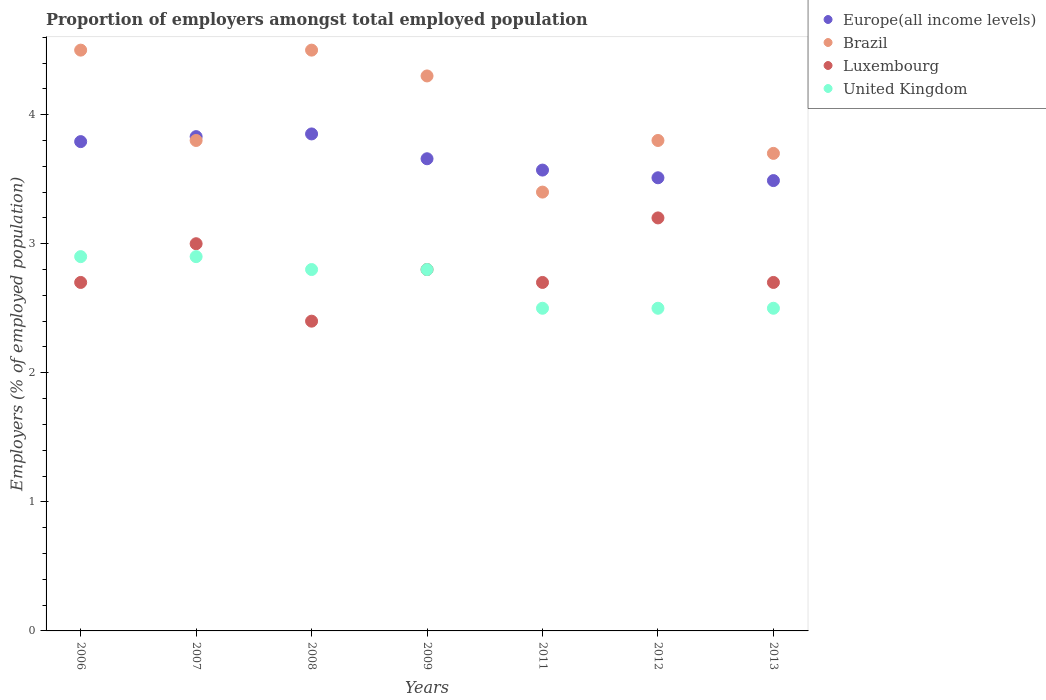What is the proportion of employers in Brazil in 2012?
Provide a succinct answer. 3.8. Across all years, what is the minimum proportion of employers in Brazil?
Your answer should be compact. 3.4. In which year was the proportion of employers in Luxembourg minimum?
Make the answer very short. 2008. What is the total proportion of employers in Luxembourg in the graph?
Ensure brevity in your answer.  19.5. What is the difference between the proportion of employers in Europe(all income levels) in 2006 and the proportion of employers in Brazil in 2008?
Offer a very short reply. -0.71. What is the average proportion of employers in Europe(all income levels) per year?
Your answer should be compact. 3.67. In the year 2013, what is the difference between the proportion of employers in United Kingdom and proportion of employers in Brazil?
Your answer should be compact. -1.2. What is the ratio of the proportion of employers in United Kingdom in 2007 to that in 2011?
Ensure brevity in your answer.  1.16. Is the proportion of employers in Europe(all income levels) in 2006 less than that in 2011?
Make the answer very short. No. Is the difference between the proportion of employers in United Kingdom in 2011 and 2012 greater than the difference between the proportion of employers in Brazil in 2011 and 2012?
Offer a very short reply. Yes. What is the difference between the highest and the second highest proportion of employers in Europe(all income levels)?
Provide a short and direct response. 0.02. What is the difference between the highest and the lowest proportion of employers in Europe(all income levels)?
Ensure brevity in your answer.  0.36. In how many years, is the proportion of employers in Europe(all income levels) greater than the average proportion of employers in Europe(all income levels) taken over all years?
Ensure brevity in your answer.  3. Is the sum of the proportion of employers in United Kingdom in 2008 and 2013 greater than the maximum proportion of employers in Europe(all income levels) across all years?
Offer a very short reply. Yes. Does the proportion of employers in United Kingdom monotonically increase over the years?
Your response must be concise. No. Is the proportion of employers in Luxembourg strictly greater than the proportion of employers in Brazil over the years?
Offer a very short reply. No. Is the proportion of employers in Europe(all income levels) strictly less than the proportion of employers in United Kingdom over the years?
Make the answer very short. No. How many dotlines are there?
Offer a very short reply. 4. What is the difference between two consecutive major ticks on the Y-axis?
Keep it short and to the point. 1. Where does the legend appear in the graph?
Your answer should be very brief. Top right. How many legend labels are there?
Your answer should be very brief. 4. How are the legend labels stacked?
Give a very brief answer. Vertical. What is the title of the graph?
Your response must be concise. Proportion of employers amongst total employed population. What is the label or title of the X-axis?
Offer a very short reply. Years. What is the label or title of the Y-axis?
Provide a short and direct response. Employers (% of employed population). What is the Employers (% of employed population) of Europe(all income levels) in 2006?
Keep it short and to the point. 3.79. What is the Employers (% of employed population) in Luxembourg in 2006?
Your response must be concise. 2.7. What is the Employers (% of employed population) in United Kingdom in 2006?
Make the answer very short. 2.9. What is the Employers (% of employed population) of Europe(all income levels) in 2007?
Your answer should be very brief. 3.83. What is the Employers (% of employed population) in Brazil in 2007?
Your response must be concise. 3.8. What is the Employers (% of employed population) of United Kingdom in 2007?
Your response must be concise. 2.9. What is the Employers (% of employed population) in Europe(all income levels) in 2008?
Offer a terse response. 3.85. What is the Employers (% of employed population) of Brazil in 2008?
Make the answer very short. 4.5. What is the Employers (% of employed population) of Luxembourg in 2008?
Make the answer very short. 2.4. What is the Employers (% of employed population) of United Kingdom in 2008?
Your answer should be compact. 2.8. What is the Employers (% of employed population) in Europe(all income levels) in 2009?
Offer a very short reply. 3.66. What is the Employers (% of employed population) of Brazil in 2009?
Your response must be concise. 4.3. What is the Employers (% of employed population) of Luxembourg in 2009?
Make the answer very short. 2.8. What is the Employers (% of employed population) in United Kingdom in 2009?
Your answer should be compact. 2.8. What is the Employers (% of employed population) in Europe(all income levels) in 2011?
Give a very brief answer. 3.57. What is the Employers (% of employed population) of Brazil in 2011?
Keep it short and to the point. 3.4. What is the Employers (% of employed population) in Luxembourg in 2011?
Your answer should be very brief. 2.7. What is the Employers (% of employed population) of Europe(all income levels) in 2012?
Provide a short and direct response. 3.51. What is the Employers (% of employed population) of Brazil in 2012?
Your response must be concise. 3.8. What is the Employers (% of employed population) of Luxembourg in 2012?
Keep it short and to the point. 3.2. What is the Employers (% of employed population) of Europe(all income levels) in 2013?
Provide a short and direct response. 3.49. What is the Employers (% of employed population) of Brazil in 2013?
Keep it short and to the point. 3.7. What is the Employers (% of employed population) of Luxembourg in 2013?
Ensure brevity in your answer.  2.7. Across all years, what is the maximum Employers (% of employed population) of Europe(all income levels)?
Offer a very short reply. 3.85. Across all years, what is the maximum Employers (% of employed population) in Luxembourg?
Your response must be concise. 3.2. Across all years, what is the maximum Employers (% of employed population) in United Kingdom?
Give a very brief answer. 2.9. Across all years, what is the minimum Employers (% of employed population) in Europe(all income levels)?
Provide a short and direct response. 3.49. Across all years, what is the minimum Employers (% of employed population) of Brazil?
Offer a very short reply. 3.4. Across all years, what is the minimum Employers (% of employed population) in Luxembourg?
Provide a succinct answer. 2.4. What is the total Employers (% of employed population) in Europe(all income levels) in the graph?
Offer a very short reply. 25.7. What is the total Employers (% of employed population) in Brazil in the graph?
Provide a short and direct response. 28. What is the total Employers (% of employed population) in Luxembourg in the graph?
Your response must be concise. 19.5. What is the difference between the Employers (% of employed population) in Europe(all income levels) in 2006 and that in 2007?
Ensure brevity in your answer.  -0.04. What is the difference between the Employers (% of employed population) of Luxembourg in 2006 and that in 2007?
Provide a short and direct response. -0.3. What is the difference between the Employers (% of employed population) of United Kingdom in 2006 and that in 2007?
Provide a succinct answer. 0. What is the difference between the Employers (% of employed population) in Europe(all income levels) in 2006 and that in 2008?
Give a very brief answer. -0.06. What is the difference between the Employers (% of employed population) of Brazil in 2006 and that in 2008?
Keep it short and to the point. 0. What is the difference between the Employers (% of employed population) of Luxembourg in 2006 and that in 2008?
Offer a very short reply. 0.3. What is the difference between the Employers (% of employed population) of United Kingdom in 2006 and that in 2008?
Offer a very short reply. 0.1. What is the difference between the Employers (% of employed population) of Europe(all income levels) in 2006 and that in 2009?
Make the answer very short. 0.13. What is the difference between the Employers (% of employed population) in Europe(all income levels) in 2006 and that in 2011?
Your response must be concise. 0.22. What is the difference between the Employers (% of employed population) of Luxembourg in 2006 and that in 2011?
Keep it short and to the point. 0. What is the difference between the Employers (% of employed population) in Europe(all income levels) in 2006 and that in 2012?
Give a very brief answer. 0.28. What is the difference between the Employers (% of employed population) of United Kingdom in 2006 and that in 2012?
Your answer should be compact. 0.4. What is the difference between the Employers (% of employed population) in Europe(all income levels) in 2006 and that in 2013?
Your answer should be compact. 0.3. What is the difference between the Employers (% of employed population) in Luxembourg in 2006 and that in 2013?
Provide a succinct answer. 0. What is the difference between the Employers (% of employed population) of Europe(all income levels) in 2007 and that in 2008?
Your answer should be compact. -0.02. What is the difference between the Employers (% of employed population) of Brazil in 2007 and that in 2008?
Offer a terse response. -0.7. What is the difference between the Employers (% of employed population) of Luxembourg in 2007 and that in 2008?
Your answer should be compact. 0.6. What is the difference between the Employers (% of employed population) of Europe(all income levels) in 2007 and that in 2009?
Your response must be concise. 0.17. What is the difference between the Employers (% of employed population) of Luxembourg in 2007 and that in 2009?
Your answer should be very brief. 0.2. What is the difference between the Employers (% of employed population) of Europe(all income levels) in 2007 and that in 2011?
Your answer should be compact. 0.26. What is the difference between the Employers (% of employed population) in Brazil in 2007 and that in 2011?
Provide a short and direct response. 0.4. What is the difference between the Employers (% of employed population) of United Kingdom in 2007 and that in 2011?
Provide a short and direct response. 0.4. What is the difference between the Employers (% of employed population) of Europe(all income levels) in 2007 and that in 2012?
Offer a very short reply. 0.32. What is the difference between the Employers (% of employed population) of Luxembourg in 2007 and that in 2012?
Give a very brief answer. -0.2. What is the difference between the Employers (% of employed population) of Europe(all income levels) in 2007 and that in 2013?
Ensure brevity in your answer.  0.34. What is the difference between the Employers (% of employed population) of Brazil in 2007 and that in 2013?
Your answer should be compact. 0.1. What is the difference between the Employers (% of employed population) in Europe(all income levels) in 2008 and that in 2009?
Offer a terse response. 0.19. What is the difference between the Employers (% of employed population) in Brazil in 2008 and that in 2009?
Offer a terse response. 0.2. What is the difference between the Employers (% of employed population) of United Kingdom in 2008 and that in 2009?
Make the answer very short. 0. What is the difference between the Employers (% of employed population) in Europe(all income levels) in 2008 and that in 2011?
Offer a terse response. 0.28. What is the difference between the Employers (% of employed population) in Brazil in 2008 and that in 2011?
Keep it short and to the point. 1.1. What is the difference between the Employers (% of employed population) in United Kingdom in 2008 and that in 2011?
Offer a very short reply. 0.3. What is the difference between the Employers (% of employed population) of Europe(all income levels) in 2008 and that in 2012?
Your answer should be compact. 0.34. What is the difference between the Employers (% of employed population) of Europe(all income levels) in 2008 and that in 2013?
Give a very brief answer. 0.36. What is the difference between the Employers (% of employed population) in Brazil in 2008 and that in 2013?
Offer a terse response. 0.8. What is the difference between the Employers (% of employed population) in Luxembourg in 2008 and that in 2013?
Your answer should be compact. -0.3. What is the difference between the Employers (% of employed population) of United Kingdom in 2008 and that in 2013?
Your answer should be very brief. 0.3. What is the difference between the Employers (% of employed population) of Europe(all income levels) in 2009 and that in 2011?
Your answer should be very brief. 0.09. What is the difference between the Employers (% of employed population) in Brazil in 2009 and that in 2011?
Give a very brief answer. 0.9. What is the difference between the Employers (% of employed population) of Luxembourg in 2009 and that in 2011?
Your answer should be compact. 0.1. What is the difference between the Employers (% of employed population) in Europe(all income levels) in 2009 and that in 2012?
Give a very brief answer. 0.15. What is the difference between the Employers (% of employed population) of Luxembourg in 2009 and that in 2012?
Ensure brevity in your answer.  -0.4. What is the difference between the Employers (% of employed population) in United Kingdom in 2009 and that in 2012?
Make the answer very short. 0.3. What is the difference between the Employers (% of employed population) of Europe(all income levels) in 2009 and that in 2013?
Ensure brevity in your answer.  0.17. What is the difference between the Employers (% of employed population) in Brazil in 2009 and that in 2013?
Provide a succinct answer. 0.6. What is the difference between the Employers (% of employed population) in Luxembourg in 2009 and that in 2013?
Offer a very short reply. 0.1. What is the difference between the Employers (% of employed population) of United Kingdom in 2009 and that in 2013?
Your answer should be compact. 0.3. What is the difference between the Employers (% of employed population) in Europe(all income levels) in 2011 and that in 2012?
Offer a terse response. 0.06. What is the difference between the Employers (% of employed population) in Brazil in 2011 and that in 2012?
Ensure brevity in your answer.  -0.4. What is the difference between the Employers (% of employed population) in United Kingdom in 2011 and that in 2012?
Offer a terse response. 0. What is the difference between the Employers (% of employed population) of Europe(all income levels) in 2011 and that in 2013?
Provide a short and direct response. 0.08. What is the difference between the Employers (% of employed population) of Europe(all income levels) in 2012 and that in 2013?
Ensure brevity in your answer.  0.02. What is the difference between the Employers (% of employed population) of Brazil in 2012 and that in 2013?
Ensure brevity in your answer.  0.1. What is the difference between the Employers (% of employed population) of United Kingdom in 2012 and that in 2013?
Keep it short and to the point. 0. What is the difference between the Employers (% of employed population) of Europe(all income levels) in 2006 and the Employers (% of employed population) of Brazil in 2007?
Offer a terse response. -0.01. What is the difference between the Employers (% of employed population) in Europe(all income levels) in 2006 and the Employers (% of employed population) in Luxembourg in 2007?
Make the answer very short. 0.79. What is the difference between the Employers (% of employed population) of Europe(all income levels) in 2006 and the Employers (% of employed population) of United Kingdom in 2007?
Offer a terse response. 0.89. What is the difference between the Employers (% of employed population) of Brazil in 2006 and the Employers (% of employed population) of Luxembourg in 2007?
Offer a terse response. 1.5. What is the difference between the Employers (% of employed population) of Brazil in 2006 and the Employers (% of employed population) of United Kingdom in 2007?
Provide a succinct answer. 1.6. What is the difference between the Employers (% of employed population) in Europe(all income levels) in 2006 and the Employers (% of employed population) in Brazil in 2008?
Offer a terse response. -0.71. What is the difference between the Employers (% of employed population) of Europe(all income levels) in 2006 and the Employers (% of employed population) of Luxembourg in 2008?
Make the answer very short. 1.39. What is the difference between the Employers (% of employed population) of Europe(all income levels) in 2006 and the Employers (% of employed population) of United Kingdom in 2008?
Provide a short and direct response. 0.99. What is the difference between the Employers (% of employed population) in Brazil in 2006 and the Employers (% of employed population) in Luxembourg in 2008?
Make the answer very short. 2.1. What is the difference between the Employers (% of employed population) of Brazil in 2006 and the Employers (% of employed population) of United Kingdom in 2008?
Provide a succinct answer. 1.7. What is the difference between the Employers (% of employed population) in Luxembourg in 2006 and the Employers (% of employed population) in United Kingdom in 2008?
Keep it short and to the point. -0.1. What is the difference between the Employers (% of employed population) in Europe(all income levels) in 2006 and the Employers (% of employed population) in Brazil in 2009?
Your answer should be compact. -0.51. What is the difference between the Employers (% of employed population) of Europe(all income levels) in 2006 and the Employers (% of employed population) of Luxembourg in 2009?
Your answer should be very brief. 0.99. What is the difference between the Employers (% of employed population) in Europe(all income levels) in 2006 and the Employers (% of employed population) in United Kingdom in 2009?
Keep it short and to the point. 0.99. What is the difference between the Employers (% of employed population) in Brazil in 2006 and the Employers (% of employed population) in Luxembourg in 2009?
Provide a succinct answer. 1.7. What is the difference between the Employers (% of employed population) of Brazil in 2006 and the Employers (% of employed population) of United Kingdom in 2009?
Your answer should be compact. 1.7. What is the difference between the Employers (% of employed population) of Europe(all income levels) in 2006 and the Employers (% of employed population) of Brazil in 2011?
Give a very brief answer. 0.39. What is the difference between the Employers (% of employed population) in Europe(all income levels) in 2006 and the Employers (% of employed population) in Luxembourg in 2011?
Give a very brief answer. 1.09. What is the difference between the Employers (% of employed population) in Europe(all income levels) in 2006 and the Employers (% of employed population) in United Kingdom in 2011?
Offer a very short reply. 1.29. What is the difference between the Employers (% of employed population) of Brazil in 2006 and the Employers (% of employed population) of Luxembourg in 2011?
Your answer should be very brief. 1.8. What is the difference between the Employers (% of employed population) in Brazil in 2006 and the Employers (% of employed population) in United Kingdom in 2011?
Provide a short and direct response. 2. What is the difference between the Employers (% of employed population) in Europe(all income levels) in 2006 and the Employers (% of employed population) in Brazil in 2012?
Offer a terse response. -0.01. What is the difference between the Employers (% of employed population) of Europe(all income levels) in 2006 and the Employers (% of employed population) of Luxembourg in 2012?
Make the answer very short. 0.59. What is the difference between the Employers (% of employed population) of Europe(all income levels) in 2006 and the Employers (% of employed population) of United Kingdom in 2012?
Provide a short and direct response. 1.29. What is the difference between the Employers (% of employed population) in Brazil in 2006 and the Employers (% of employed population) in Luxembourg in 2012?
Offer a terse response. 1.3. What is the difference between the Employers (% of employed population) in Brazil in 2006 and the Employers (% of employed population) in United Kingdom in 2012?
Make the answer very short. 2. What is the difference between the Employers (% of employed population) in Luxembourg in 2006 and the Employers (% of employed population) in United Kingdom in 2012?
Provide a short and direct response. 0.2. What is the difference between the Employers (% of employed population) in Europe(all income levels) in 2006 and the Employers (% of employed population) in Brazil in 2013?
Provide a succinct answer. 0.09. What is the difference between the Employers (% of employed population) in Europe(all income levels) in 2006 and the Employers (% of employed population) in Luxembourg in 2013?
Ensure brevity in your answer.  1.09. What is the difference between the Employers (% of employed population) of Europe(all income levels) in 2006 and the Employers (% of employed population) of United Kingdom in 2013?
Ensure brevity in your answer.  1.29. What is the difference between the Employers (% of employed population) of Brazil in 2006 and the Employers (% of employed population) of Luxembourg in 2013?
Ensure brevity in your answer.  1.8. What is the difference between the Employers (% of employed population) of Brazil in 2006 and the Employers (% of employed population) of United Kingdom in 2013?
Provide a succinct answer. 2. What is the difference between the Employers (% of employed population) in Europe(all income levels) in 2007 and the Employers (% of employed population) in Brazil in 2008?
Provide a short and direct response. -0.67. What is the difference between the Employers (% of employed population) in Europe(all income levels) in 2007 and the Employers (% of employed population) in Luxembourg in 2008?
Provide a short and direct response. 1.43. What is the difference between the Employers (% of employed population) of Europe(all income levels) in 2007 and the Employers (% of employed population) of United Kingdom in 2008?
Your response must be concise. 1.03. What is the difference between the Employers (% of employed population) of Luxembourg in 2007 and the Employers (% of employed population) of United Kingdom in 2008?
Keep it short and to the point. 0.2. What is the difference between the Employers (% of employed population) in Europe(all income levels) in 2007 and the Employers (% of employed population) in Brazil in 2009?
Ensure brevity in your answer.  -0.47. What is the difference between the Employers (% of employed population) of Europe(all income levels) in 2007 and the Employers (% of employed population) of Luxembourg in 2009?
Your response must be concise. 1.03. What is the difference between the Employers (% of employed population) of Europe(all income levels) in 2007 and the Employers (% of employed population) of United Kingdom in 2009?
Provide a succinct answer. 1.03. What is the difference between the Employers (% of employed population) of Brazil in 2007 and the Employers (% of employed population) of Luxembourg in 2009?
Keep it short and to the point. 1. What is the difference between the Employers (% of employed population) of Brazil in 2007 and the Employers (% of employed population) of United Kingdom in 2009?
Provide a succinct answer. 1. What is the difference between the Employers (% of employed population) of Luxembourg in 2007 and the Employers (% of employed population) of United Kingdom in 2009?
Keep it short and to the point. 0.2. What is the difference between the Employers (% of employed population) of Europe(all income levels) in 2007 and the Employers (% of employed population) of Brazil in 2011?
Your response must be concise. 0.43. What is the difference between the Employers (% of employed population) in Europe(all income levels) in 2007 and the Employers (% of employed population) in Luxembourg in 2011?
Your answer should be very brief. 1.13. What is the difference between the Employers (% of employed population) in Europe(all income levels) in 2007 and the Employers (% of employed population) in United Kingdom in 2011?
Give a very brief answer. 1.33. What is the difference between the Employers (% of employed population) in Brazil in 2007 and the Employers (% of employed population) in Luxembourg in 2011?
Provide a short and direct response. 1.1. What is the difference between the Employers (% of employed population) in Brazil in 2007 and the Employers (% of employed population) in United Kingdom in 2011?
Provide a short and direct response. 1.3. What is the difference between the Employers (% of employed population) of Europe(all income levels) in 2007 and the Employers (% of employed population) of Brazil in 2012?
Make the answer very short. 0.03. What is the difference between the Employers (% of employed population) of Europe(all income levels) in 2007 and the Employers (% of employed population) of Luxembourg in 2012?
Make the answer very short. 0.63. What is the difference between the Employers (% of employed population) in Europe(all income levels) in 2007 and the Employers (% of employed population) in United Kingdom in 2012?
Make the answer very short. 1.33. What is the difference between the Employers (% of employed population) of Brazil in 2007 and the Employers (% of employed population) of Luxembourg in 2012?
Offer a terse response. 0.6. What is the difference between the Employers (% of employed population) of Brazil in 2007 and the Employers (% of employed population) of United Kingdom in 2012?
Your answer should be compact. 1.3. What is the difference between the Employers (% of employed population) of Europe(all income levels) in 2007 and the Employers (% of employed population) of Brazil in 2013?
Keep it short and to the point. 0.13. What is the difference between the Employers (% of employed population) of Europe(all income levels) in 2007 and the Employers (% of employed population) of Luxembourg in 2013?
Provide a short and direct response. 1.13. What is the difference between the Employers (% of employed population) of Europe(all income levels) in 2007 and the Employers (% of employed population) of United Kingdom in 2013?
Ensure brevity in your answer.  1.33. What is the difference between the Employers (% of employed population) of Brazil in 2007 and the Employers (% of employed population) of Luxembourg in 2013?
Your answer should be very brief. 1.1. What is the difference between the Employers (% of employed population) of Brazil in 2007 and the Employers (% of employed population) of United Kingdom in 2013?
Your answer should be very brief. 1.3. What is the difference between the Employers (% of employed population) in Luxembourg in 2007 and the Employers (% of employed population) in United Kingdom in 2013?
Your answer should be compact. 0.5. What is the difference between the Employers (% of employed population) of Europe(all income levels) in 2008 and the Employers (% of employed population) of Brazil in 2009?
Your answer should be compact. -0.45. What is the difference between the Employers (% of employed population) in Europe(all income levels) in 2008 and the Employers (% of employed population) in Luxembourg in 2009?
Keep it short and to the point. 1.05. What is the difference between the Employers (% of employed population) of Europe(all income levels) in 2008 and the Employers (% of employed population) of United Kingdom in 2009?
Your response must be concise. 1.05. What is the difference between the Employers (% of employed population) in Luxembourg in 2008 and the Employers (% of employed population) in United Kingdom in 2009?
Make the answer very short. -0.4. What is the difference between the Employers (% of employed population) in Europe(all income levels) in 2008 and the Employers (% of employed population) in Brazil in 2011?
Offer a very short reply. 0.45. What is the difference between the Employers (% of employed population) of Europe(all income levels) in 2008 and the Employers (% of employed population) of Luxembourg in 2011?
Provide a short and direct response. 1.15. What is the difference between the Employers (% of employed population) in Europe(all income levels) in 2008 and the Employers (% of employed population) in United Kingdom in 2011?
Your answer should be compact. 1.35. What is the difference between the Employers (% of employed population) of Brazil in 2008 and the Employers (% of employed population) of United Kingdom in 2011?
Keep it short and to the point. 2. What is the difference between the Employers (% of employed population) of Europe(all income levels) in 2008 and the Employers (% of employed population) of Brazil in 2012?
Provide a short and direct response. 0.05. What is the difference between the Employers (% of employed population) in Europe(all income levels) in 2008 and the Employers (% of employed population) in Luxembourg in 2012?
Your response must be concise. 0.65. What is the difference between the Employers (% of employed population) of Europe(all income levels) in 2008 and the Employers (% of employed population) of United Kingdom in 2012?
Make the answer very short. 1.35. What is the difference between the Employers (% of employed population) of Luxembourg in 2008 and the Employers (% of employed population) of United Kingdom in 2012?
Offer a very short reply. -0.1. What is the difference between the Employers (% of employed population) of Europe(all income levels) in 2008 and the Employers (% of employed population) of Brazil in 2013?
Keep it short and to the point. 0.15. What is the difference between the Employers (% of employed population) of Europe(all income levels) in 2008 and the Employers (% of employed population) of Luxembourg in 2013?
Offer a very short reply. 1.15. What is the difference between the Employers (% of employed population) in Europe(all income levels) in 2008 and the Employers (% of employed population) in United Kingdom in 2013?
Offer a very short reply. 1.35. What is the difference between the Employers (% of employed population) of Brazil in 2008 and the Employers (% of employed population) of Luxembourg in 2013?
Keep it short and to the point. 1.8. What is the difference between the Employers (% of employed population) in Europe(all income levels) in 2009 and the Employers (% of employed population) in Brazil in 2011?
Make the answer very short. 0.26. What is the difference between the Employers (% of employed population) of Europe(all income levels) in 2009 and the Employers (% of employed population) of Luxembourg in 2011?
Give a very brief answer. 0.96. What is the difference between the Employers (% of employed population) of Europe(all income levels) in 2009 and the Employers (% of employed population) of United Kingdom in 2011?
Your answer should be compact. 1.16. What is the difference between the Employers (% of employed population) in Europe(all income levels) in 2009 and the Employers (% of employed population) in Brazil in 2012?
Your response must be concise. -0.14. What is the difference between the Employers (% of employed population) of Europe(all income levels) in 2009 and the Employers (% of employed population) of Luxembourg in 2012?
Give a very brief answer. 0.46. What is the difference between the Employers (% of employed population) of Europe(all income levels) in 2009 and the Employers (% of employed population) of United Kingdom in 2012?
Your answer should be compact. 1.16. What is the difference between the Employers (% of employed population) in Brazil in 2009 and the Employers (% of employed population) in United Kingdom in 2012?
Your answer should be compact. 1.8. What is the difference between the Employers (% of employed population) in Europe(all income levels) in 2009 and the Employers (% of employed population) in Brazil in 2013?
Make the answer very short. -0.04. What is the difference between the Employers (% of employed population) in Europe(all income levels) in 2009 and the Employers (% of employed population) in Luxembourg in 2013?
Your response must be concise. 0.96. What is the difference between the Employers (% of employed population) of Europe(all income levels) in 2009 and the Employers (% of employed population) of United Kingdom in 2013?
Offer a very short reply. 1.16. What is the difference between the Employers (% of employed population) in Luxembourg in 2009 and the Employers (% of employed population) in United Kingdom in 2013?
Make the answer very short. 0.3. What is the difference between the Employers (% of employed population) of Europe(all income levels) in 2011 and the Employers (% of employed population) of Brazil in 2012?
Give a very brief answer. -0.23. What is the difference between the Employers (% of employed population) in Europe(all income levels) in 2011 and the Employers (% of employed population) in Luxembourg in 2012?
Offer a very short reply. 0.37. What is the difference between the Employers (% of employed population) of Europe(all income levels) in 2011 and the Employers (% of employed population) of United Kingdom in 2012?
Make the answer very short. 1.07. What is the difference between the Employers (% of employed population) of Brazil in 2011 and the Employers (% of employed population) of United Kingdom in 2012?
Keep it short and to the point. 0.9. What is the difference between the Employers (% of employed population) of Europe(all income levels) in 2011 and the Employers (% of employed population) of Brazil in 2013?
Provide a short and direct response. -0.13. What is the difference between the Employers (% of employed population) of Europe(all income levels) in 2011 and the Employers (% of employed population) of Luxembourg in 2013?
Your answer should be very brief. 0.87. What is the difference between the Employers (% of employed population) in Europe(all income levels) in 2011 and the Employers (% of employed population) in United Kingdom in 2013?
Give a very brief answer. 1.07. What is the difference between the Employers (% of employed population) in Brazil in 2011 and the Employers (% of employed population) in Luxembourg in 2013?
Ensure brevity in your answer.  0.7. What is the difference between the Employers (% of employed population) of Brazil in 2011 and the Employers (% of employed population) of United Kingdom in 2013?
Your answer should be compact. 0.9. What is the difference between the Employers (% of employed population) in Europe(all income levels) in 2012 and the Employers (% of employed population) in Brazil in 2013?
Your answer should be very brief. -0.19. What is the difference between the Employers (% of employed population) of Europe(all income levels) in 2012 and the Employers (% of employed population) of Luxembourg in 2013?
Make the answer very short. 0.81. What is the difference between the Employers (% of employed population) in Brazil in 2012 and the Employers (% of employed population) in United Kingdom in 2013?
Keep it short and to the point. 1.3. What is the average Employers (% of employed population) of Europe(all income levels) per year?
Your answer should be compact. 3.67. What is the average Employers (% of employed population) in Brazil per year?
Provide a short and direct response. 4. What is the average Employers (% of employed population) in Luxembourg per year?
Your answer should be compact. 2.79. What is the average Employers (% of employed population) in United Kingdom per year?
Ensure brevity in your answer.  2.7. In the year 2006, what is the difference between the Employers (% of employed population) of Europe(all income levels) and Employers (% of employed population) of Brazil?
Give a very brief answer. -0.71. In the year 2006, what is the difference between the Employers (% of employed population) of Europe(all income levels) and Employers (% of employed population) of Luxembourg?
Your answer should be compact. 1.09. In the year 2006, what is the difference between the Employers (% of employed population) of Europe(all income levels) and Employers (% of employed population) of United Kingdom?
Your answer should be very brief. 0.89. In the year 2006, what is the difference between the Employers (% of employed population) of Brazil and Employers (% of employed population) of United Kingdom?
Your response must be concise. 1.6. In the year 2007, what is the difference between the Employers (% of employed population) of Europe(all income levels) and Employers (% of employed population) of Brazil?
Make the answer very short. 0.03. In the year 2007, what is the difference between the Employers (% of employed population) of Europe(all income levels) and Employers (% of employed population) of Luxembourg?
Provide a short and direct response. 0.83. In the year 2007, what is the difference between the Employers (% of employed population) of Europe(all income levels) and Employers (% of employed population) of United Kingdom?
Your answer should be compact. 0.93. In the year 2007, what is the difference between the Employers (% of employed population) in Brazil and Employers (% of employed population) in Luxembourg?
Ensure brevity in your answer.  0.8. In the year 2007, what is the difference between the Employers (% of employed population) of Luxembourg and Employers (% of employed population) of United Kingdom?
Your answer should be very brief. 0.1. In the year 2008, what is the difference between the Employers (% of employed population) in Europe(all income levels) and Employers (% of employed population) in Brazil?
Offer a very short reply. -0.65. In the year 2008, what is the difference between the Employers (% of employed population) in Europe(all income levels) and Employers (% of employed population) in Luxembourg?
Keep it short and to the point. 1.45. In the year 2008, what is the difference between the Employers (% of employed population) of Europe(all income levels) and Employers (% of employed population) of United Kingdom?
Your answer should be very brief. 1.05. In the year 2008, what is the difference between the Employers (% of employed population) of Brazil and Employers (% of employed population) of Luxembourg?
Offer a terse response. 2.1. In the year 2008, what is the difference between the Employers (% of employed population) of Brazil and Employers (% of employed population) of United Kingdom?
Give a very brief answer. 1.7. In the year 2008, what is the difference between the Employers (% of employed population) in Luxembourg and Employers (% of employed population) in United Kingdom?
Offer a very short reply. -0.4. In the year 2009, what is the difference between the Employers (% of employed population) of Europe(all income levels) and Employers (% of employed population) of Brazil?
Keep it short and to the point. -0.64. In the year 2009, what is the difference between the Employers (% of employed population) in Europe(all income levels) and Employers (% of employed population) in Luxembourg?
Your answer should be compact. 0.86. In the year 2009, what is the difference between the Employers (% of employed population) of Europe(all income levels) and Employers (% of employed population) of United Kingdom?
Give a very brief answer. 0.86. In the year 2009, what is the difference between the Employers (% of employed population) in Luxembourg and Employers (% of employed population) in United Kingdom?
Your response must be concise. 0. In the year 2011, what is the difference between the Employers (% of employed population) in Europe(all income levels) and Employers (% of employed population) in Brazil?
Your answer should be compact. 0.17. In the year 2011, what is the difference between the Employers (% of employed population) of Europe(all income levels) and Employers (% of employed population) of Luxembourg?
Offer a terse response. 0.87. In the year 2011, what is the difference between the Employers (% of employed population) of Europe(all income levels) and Employers (% of employed population) of United Kingdom?
Keep it short and to the point. 1.07. In the year 2011, what is the difference between the Employers (% of employed population) in Brazil and Employers (% of employed population) in Luxembourg?
Ensure brevity in your answer.  0.7. In the year 2011, what is the difference between the Employers (% of employed population) in Brazil and Employers (% of employed population) in United Kingdom?
Give a very brief answer. 0.9. In the year 2012, what is the difference between the Employers (% of employed population) of Europe(all income levels) and Employers (% of employed population) of Brazil?
Keep it short and to the point. -0.29. In the year 2012, what is the difference between the Employers (% of employed population) in Europe(all income levels) and Employers (% of employed population) in Luxembourg?
Offer a very short reply. 0.31. In the year 2012, what is the difference between the Employers (% of employed population) in Brazil and Employers (% of employed population) in Luxembourg?
Provide a succinct answer. 0.6. In the year 2012, what is the difference between the Employers (% of employed population) of Brazil and Employers (% of employed population) of United Kingdom?
Ensure brevity in your answer.  1.3. In the year 2013, what is the difference between the Employers (% of employed population) in Europe(all income levels) and Employers (% of employed population) in Brazil?
Provide a succinct answer. -0.21. In the year 2013, what is the difference between the Employers (% of employed population) in Europe(all income levels) and Employers (% of employed population) in Luxembourg?
Offer a terse response. 0.79. What is the ratio of the Employers (% of employed population) of Europe(all income levels) in 2006 to that in 2007?
Provide a short and direct response. 0.99. What is the ratio of the Employers (% of employed population) in Brazil in 2006 to that in 2007?
Offer a very short reply. 1.18. What is the ratio of the Employers (% of employed population) of Luxembourg in 2006 to that in 2007?
Give a very brief answer. 0.9. What is the ratio of the Employers (% of employed population) of Europe(all income levels) in 2006 to that in 2008?
Your answer should be compact. 0.98. What is the ratio of the Employers (% of employed population) of Brazil in 2006 to that in 2008?
Keep it short and to the point. 1. What is the ratio of the Employers (% of employed population) of Luxembourg in 2006 to that in 2008?
Ensure brevity in your answer.  1.12. What is the ratio of the Employers (% of employed population) in United Kingdom in 2006 to that in 2008?
Your response must be concise. 1.04. What is the ratio of the Employers (% of employed population) of Europe(all income levels) in 2006 to that in 2009?
Your answer should be compact. 1.04. What is the ratio of the Employers (% of employed population) in Brazil in 2006 to that in 2009?
Provide a succinct answer. 1.05. What is the ratio of the Employers (% of employed population) of United Kingdom in 2006 to that in 2009?
Offer a very short reply. 1.04. What is the ratio of the Employers (% of employed population) in Europe(all income levels) in 2006 to that in 2011?
Your response must be concise. 1.06. What is the ratio of the Employers (% of employed population) in Brazil in 2006 to that in 2011?
Your answer should be compact. 1.32. What is the ratio of the Employers (% of employed population) in Luxembourg in 2006 to that in 2011?
Your answer should be compact. 1. What is the ratio of the Employers (% of employed population) in United Kingdom in 2006 to that in 2011?
Your response must be concise. 1.16. What is the ratio of the Employers (% of employed population) of Europe(all income levels) in 2006 to that in 2012?
Your answer should be very brief. 1.08. What is the ratio of the Employers (% of employed population) in Brazil in 2006 to that in 2012?
Keep it short and to the point. 1.18. What is the ratio of the Employers (% of employed population) in Luxembourg in 2006 to that in 2012?
Provide a short and direct response. 0.84. What is the ratio of the Employers (% of employed population) of United Kingdom in 2006 to that in 2012?
Offer a very short reply. 1.16. What is the ratio of the Employers (% of employed population) of Europe(all income levels) in 2006 to that in 2013?
Your answer should be compact. 1.09. What is the ratio of the Employers (% of employed population) of Brazil in 2006 to that in 2013?
Offer a terse response. 1.22. What is the ratio of the Employers (% of employed population) of United Kingdom in 2006 to that in 2013?
Your answer should be very brief. 1.16. What is the ratio of the Employers (% of employed population) of Brazil in 2007 to that in 2008?
Your answer should be compact. 0.84. What is the ratio of the Employers (% of employed population) of Luxembourg in 2007 to that in 2008?
Your answer should be very brief. 1.25. What is the ratio of the Employers (% of employed population) in United Kingdom in 2007 to that in 2008?
Keep it short and to the point. 1.04. What is the ratio of the Employers (% of employed population) in Europe(all income levels) in 2007 to that in 2009?
Offer a very short reply. 1.05. What is the ratio of the Employers (% of employed population) in Brazil in 2007 to that in 2009?
Your response must be concise. 0.88. What is the ratio of the Employers (% of employed population) of Luxembourg in 2007 to that in 2009?
Keep it short and to the point. 1.07. What is the ratio of the Employers (% of employed population) in United Kingdom in 2007 to that in 2009?
Ensure brevity in your answer.  1.04. What is the ratio of the Employers (% of employed population) in Europe(all income levels) in 2007 to that in 2011?
Make the answer very short. 1.07. What is the ratio of the Employers (% of employed population) of Brazil in 2007 to that in 2011?
Keep it short and to the point. 1.12. What is the ratio of the Employers (% of employed population) of Luxembourg in 2007 to that in 2011?
Provide a succinct answer. 1.11. What is the ratio of the Employers (% of employed population) of United Kingdom in 2007 to that in 2011?
Your answer should be compact. 1.16. What is the ratio of the Employers (% of employed population) in Europe(all income levels) in 2007 to that in 2012?
Provide a succinct answer. 1.09. What is the ratio of the Employers (% of employed population) of Brazil in 2007 to that in 2012?
Offer a terse response. 1. What is the ratio of the Employers (% of employed population) in Luxembourg in 2007 to that in 2012?
Your response must be concise. 0.94. What is the ratio of the Employers (% of employed population) of United Kingdom in 2007 to that in 2012?
Keep it short and to the point. 1.16. What is the ratio of the Employers (% of employed population) of Europe(all income levels) in 2007 to that in 2013?
Give a very brief answer. 1.1. What is the ratio of the Employers (% of employed population) in Luxembourg in 2007 to that in 2013?
Offer a very short reply. 1.11. What is the ratio of the Employers (% of employed population) of United Kingdom in 2007 to that in 2013?
Your answer should be compact. 1.16. What is the ratio of the Employers (% of employed population) in Europe(all income levels) in 2008 to that in 2009?
Provide a succinct answer. 1.05. What is the ratio of the Employers (% of employed population) in Brazil in 2008 to that in 2009?
Your response must be concise. 1.05. What is the ratio of the Employers (% of employed population) of United Kingdom in 2008 to that in 2009?
Your answer should be very brief. 1. What is the ratio of the Employers (% of employed population) in Europe(all income levels) in 2008 to that in 2011?
Provide a succinct answer. 1.08. What is the ratio of the Employers (% of employed population) in Brazil in 2008 to that in 2011?
Provide a short and direct response. 1.32. What is the ratio of the Employers (% of employed population) in Luxembourg in 2008 to that in 2011?
Provide a succinct answer. 0.89. What is the ratio of the Employers (% of employed population) in United Kingdom in 2008 to that in 2011?
Your response must be concise. 1.12. What is the ratio of the Employers (% of employed population) of Europe(all income levels) in 2008 to that in 2012?
Keep it short and to the point. 1.1. What is the ratio of the Employers (% of employed population) of Brazil in 2008 to that in 2012?
Provide a succinct answer. 1.18. What is the ratio of the Employers (% of employed population) in United Kingdom in 2008 to that in 2012?
Offer a terse response. 1.12. What is the ratio of the Employers (% of employed population) in Europe(all income levels) in 2008 to that in 2013?
Provide a short and direct response. 1.1. What is the ratio of the Employers (% of employed population) in Brazil in 2008 to that in 2013?
Keep it short and to the point. 1.22. What is the ratio of the Employers (% of employed population) of United Kingdom in 2008 to that in 2013?
Make the answer very short. 1.12. What is the ratio of the Employers (% of employed population) of Europe(all income levels) in 2009 to that in 2011?
Give a very brief answer. 1.02. What is the ratio of the Employers (% of employed population) in Brazil in 2009 to that in 2011?
Provide a succinct answer. 1.26. What is the ratio of the Employers (% of employed population) in Luxembourg in 2009 to that in 2011?
Offer a terse response. 1.04. What is the ratio of the Employers (% of employed population) in United Kingdom in 2009 to that in 2011?
Offer a terse response. 1.12. What is the ratio of the Employers (% of employed population) of Europe(all income levels) in 2009 to that in 2012?
Make the answer very short. 1.04. What is the ratio of the Employers (% of employed population) in Brazil in 2009 to that in 2012?
Offer a terse response. 1.13. What is the ratio of the Employers (% of employed population) in United Kingdom in 2009 to that in 2012?
Your response must be concise. 1.12. What is the ratio of the Employers (% of employed population) of Europe(all income levels) in 2009 to that in 2013?
Your answer should be compact. 1.05. What is the ratio of the Employers (% of employed population) in Brazil in 2009 to that in 2013?
Offer a very short reply. 1.16. What is the ratio of the Employers (% of employed population) of Luxembourg in 2009 to that in 2013?
Provide a succinct answer. 1.04. What is the ratio of the Employers (% of employed population) of United Kingdom in 2009 to that in 2013?
Ensure brevity in your answer.  1.12. What is the ratio of the Employers (% of employed population) in Brazil in 2011 to that in 2012?
Your response must be concise. 0.89. What is the ratio of the Employers (% of employed population) of Luxembourg in 2011 to that in 2012?
Keep it short and to the point. 0.84. What is the ratio of the Employers (% of employed population) in Europe(all income levels) in 2011 to that in 2013?
Give a very brief answer. 1.02. What is the ratio of the Employers (% of employed population) in Brazil in 2011 to that in 2013?
Offer a very short reply. 0.92. What is the ratio of the Employers (% of employed population) of Luxembourg in 2011 to that in 2013?
Provide a succinct answer. 1. What is the ratio of the Employers (% of employed population) in United Kingdom in 2011 to that in 2013?
Your response must be concise. 1. What is the ratio of the Employers (% of employed population) of Luxembourg in 2012 to that in 2013?
Your answer should be compact. 1.19. What is the ratio of the Employers (% of employed population) in United Kingdom in 2012 to that in 2013?
Provide a short and direct response. 1. What is the difference between the highest and the second highest Employers (% of employed population) in Europe(all income levels)?
Your response must be concise. 0.02. What is the difference between the highest and the lowest Employers (% of employed population) of Europe(all income levels)?
Your response must be concise. 0.36. What is the difference between the highest and the lowest Employers (% of employed population) of Brazil?
Make the answer very short. 1.1. 